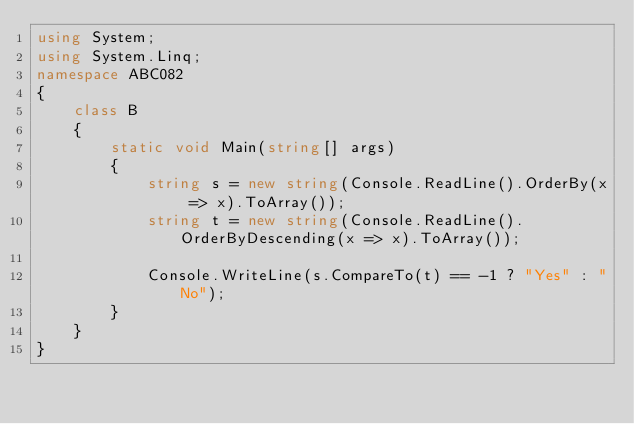<code> <loc_0><loc_0><loc_500><loc_500><_C#_>using System;
using System.Linq;
namespace ABC082
{
    class B
    {
        static void Main(string[] args)
        {
            string s = new string(Console.ReadLine().OrderBy(x => x).ToArray());
            string t = new string(Console.ReadLine().OrderByDescending(x => x).ToArray());

            Console.WriteLine(s.CompareTo(t) == -1 ? "Yes" : "No");
        }
    }
}
</code> 